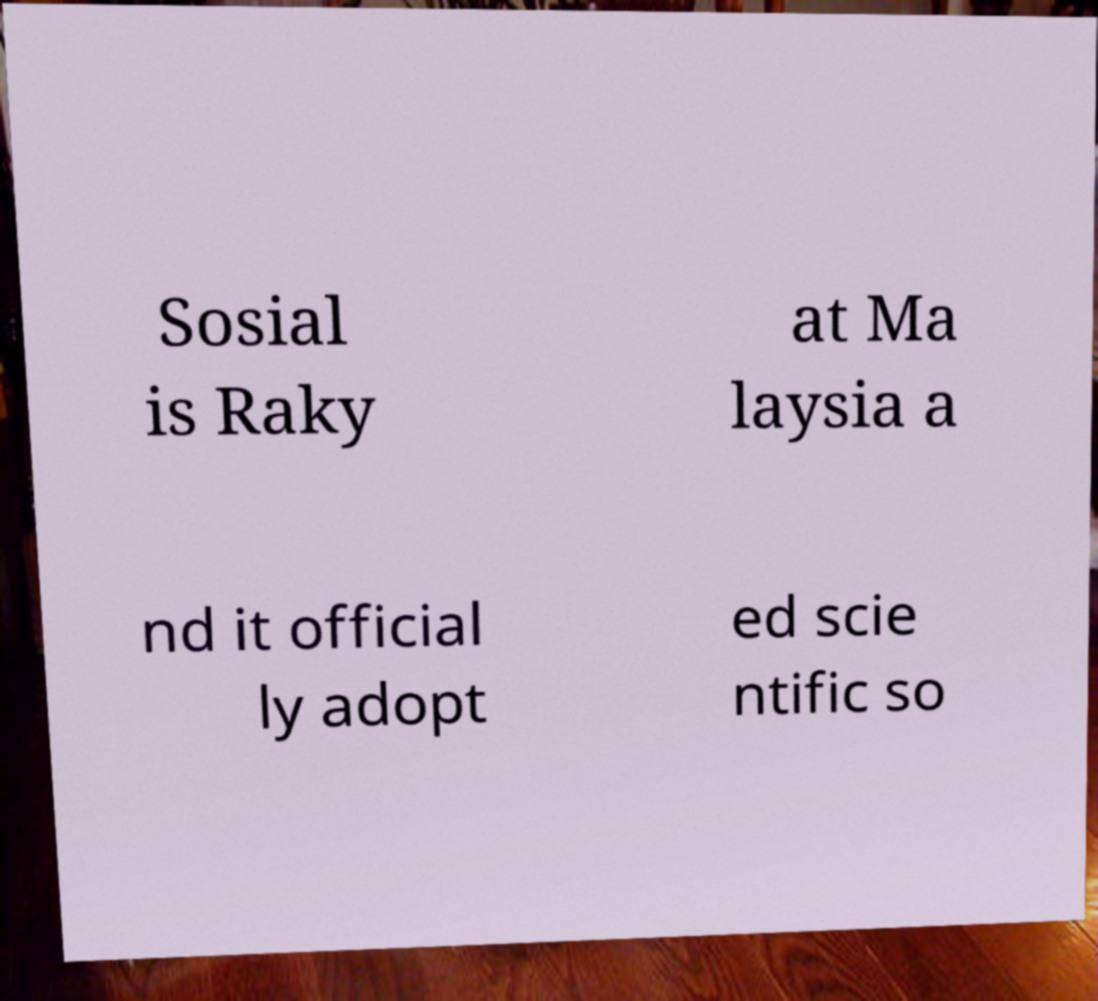What messages or text are displayed in this image? I need them in a readable, typed format. Sosial is Raky at Ma laysia a nd it official ly adopt ed scie ntific so 